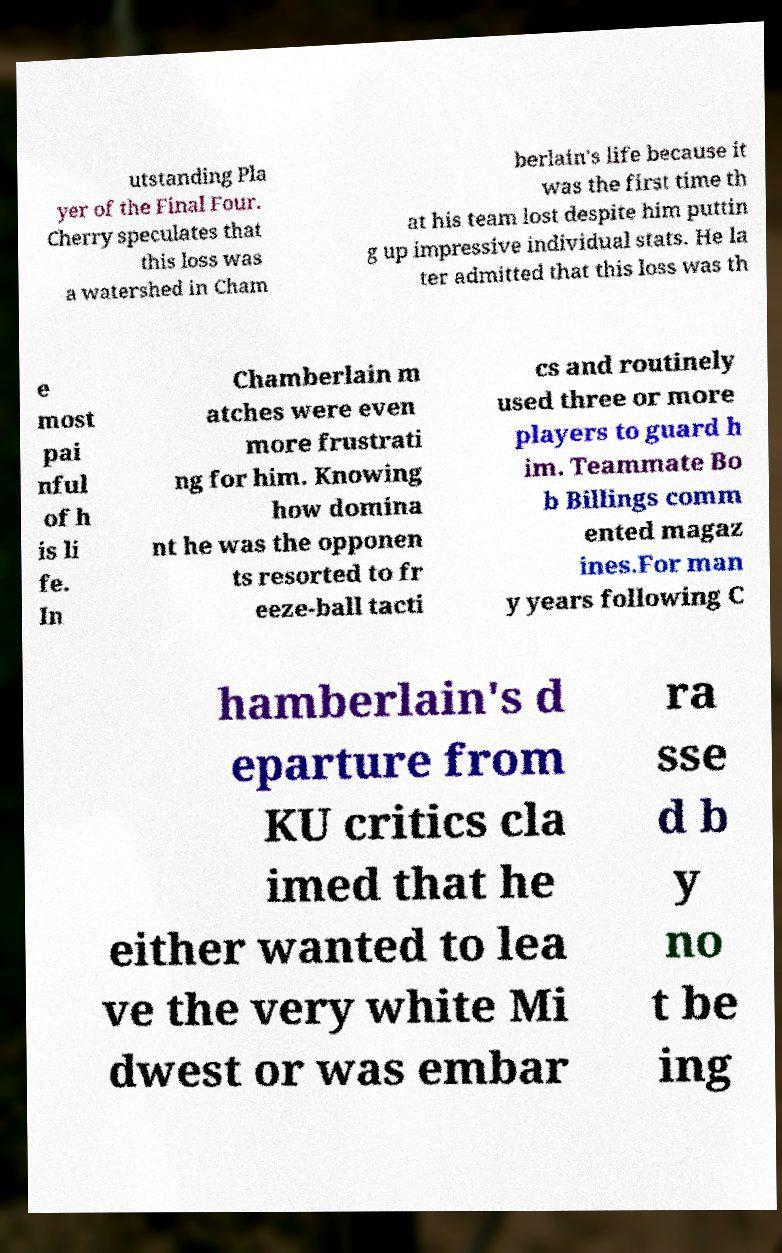There's text embedded in this image that I need extracted. Can you transcribe it verbatim? utstanding Pla yer of the Final Four. Cherry speculates that this loss was a watershed in Cham berlain's life because it was the first time th at his team lost despite him puttin g up impressive individual stats. He la ter admitted that this loss was th e most pai nful of h is li fe. In Chamberlain m atches were even more frustrati ng for him. Knowing how domina nt he was the opponen ts resorted to fr eeze-ball tacti cs and routinely used three or more players to guard h im. Teammate Bo b Billings comm ented magaz ines.For man y years following C hamberlain's d eparture from KU critics cla imed that he either wanted to lea ve the very white Mi dwest or was embar ra sse d b y no t be ing 